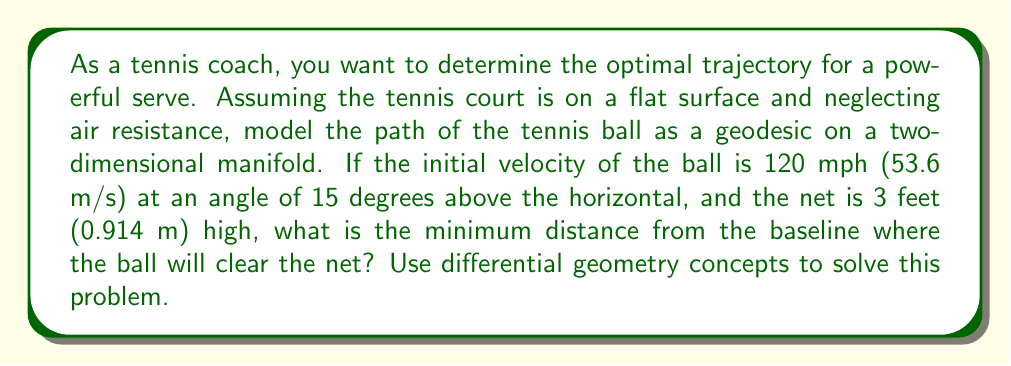Can you solve this math problem? To solve this problem, we'll use concepts from differential geometry and classical mechanics. We'll model the tennis court as a flat two-dimensional manifold and the ball's trajectory as a geodesic on this manifold.

1. First, let's set up our coordinate system:
   - x-axis: horizontal distance along the court
   - y-axis: vertical height above the court

2. The equation of motion for a projectile in a uniform gravitational field (neglecting air resistance) is:

   $$y = x \tan\theta - \frac{gx^2}{2v_0^2\cos^2\theta}$$

   where:
   - $\theta$ is the initial angle (15 degrees)
   - $v_0$ is the initial velocity (53.6 m/s)
   - $g$ is the acceleration due to gravity (9.81 m/s²)

3. Convert the angle to radians:
   $$\theta = 15° \times \frac{\pi}{180°} = 0.2618 \text{ rad}$$

4. Substitute the values into the equation:

   $$y = x \tan(0.2618) - \frac{9.81x^2}{2(53.6)^2\cos^2(0.2618)}$$

5. Simplify:

   $$y = 0.2679x - 0.001727x^2$$

6. To find where the ball clears the net, we need to solve:

   $$0.914 = 0.2679x - 0.001727x^2$$

7. Rearrange to standard quadratic form:

   $$0.001727x^2 - 0.2679x + 0.914 = 0$$

8. Solve using the quadratic formula:

   $$x = \frac{-b \pm \sqrt{b^2 - 4ac}}{2a}$$

   where $a = 0.001727$, $b = -0.2679$, and $c = 0.914$

9. Calculate:

   $$x = \frac{0.2679 \pm \sqrt{0.2679^2 - 4(0.001727)(0.914)}}{2(0.001727)}$$

10. Solve and choose the smaller positive root (as we want the first crossing point):

    $$x \approx 11.89 \text{ m}$$

This distance represents the point where the ball first crosses the height of the net. The minimum distance from the baseline where the ball will clear the net is slightly less than this value.
Answer: The minimum distance from the baseline where the ball will clear the net is approximately 11.89 meters (or about 39 feet). 